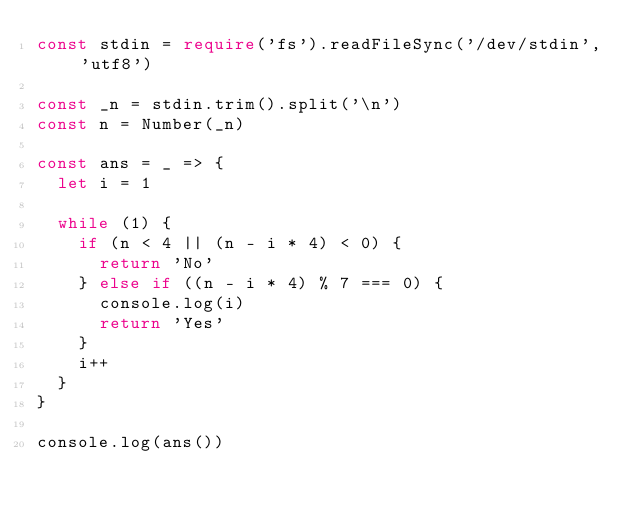<code> <loc_0><loc_0><loc_500><loc_500><_TypeScript_>const stdin = require('fs').readFileSync('/dev/stdin', 'utf8')

const _n = stdin.trim().split('\n')
const n = Number(_n)

const ans = _ => {
  let i = 1

  while (1) {
    if (n < 4 || (n - i * 4) < 0) {
      return 'No'
    } else if ((n - i * 4) % 7 === 0) {
      console.log(i)
      return 'Yes'
    }
    i++
  }
}

console.log(ans())
</code> 